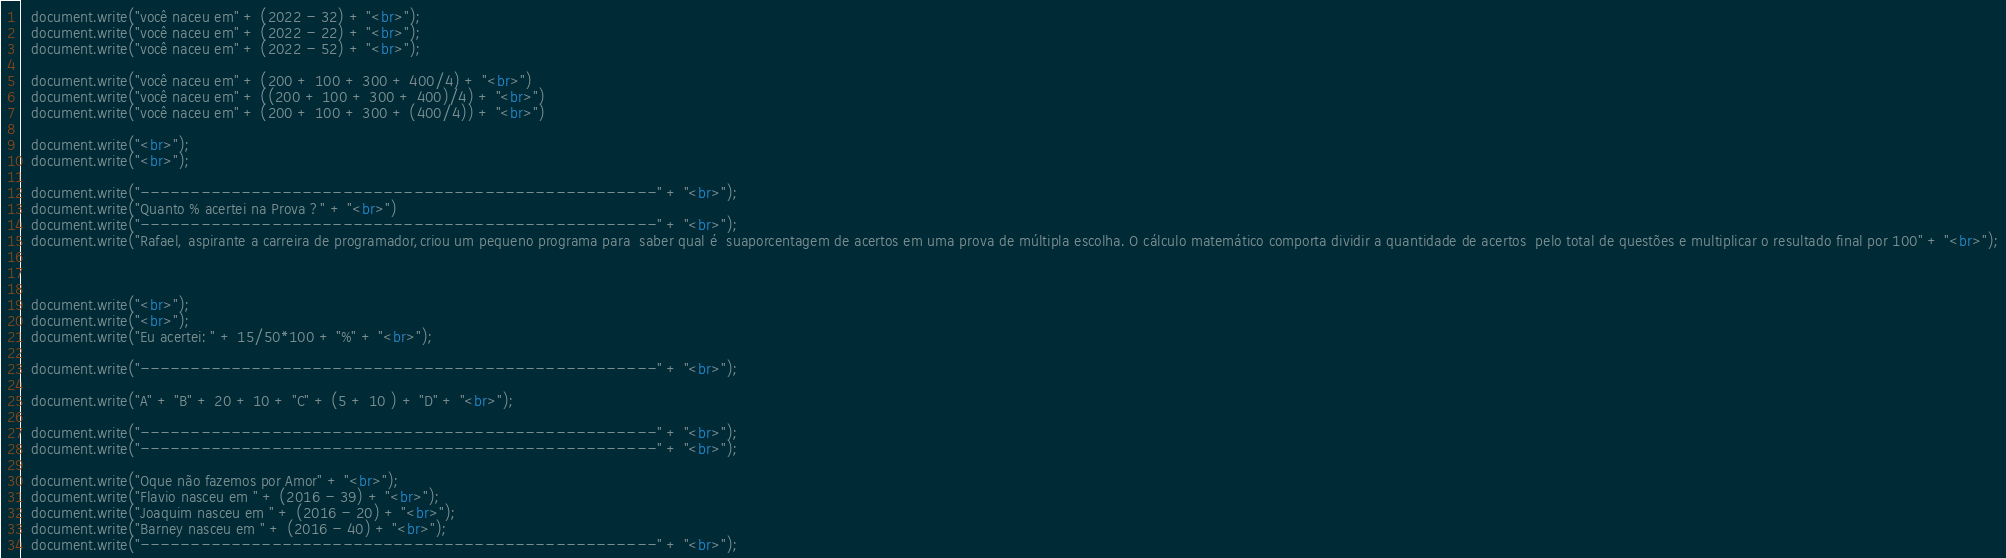Convert code to text. <code><loc_0><loc_0><loc_500><loc_500><_HTML_>
  document.write("você naceu em" + (2022 - 32) + "<br>");
  document.write("você naceu em" + (2022 - 22) + "<br>");
  document.write("você naceu em" + (2022 - 52) + "<br>");

  document.write("você naceu em" + (200 + 100 + 300 + 400/4) + "<br>")
  document.write("você naceu em" + ((200 + 100 + 300 + 400)/4) + "<br>")
  document.write("você naceu em" + (200 + 100 + 300 + (400/4)) + "<br>")

  document.write("<br>");
  document.write("<br>");

  document.write("---------------------------------------------------" + "<br>");
  document.write("Quanto % acertei na Prova ?" + "<br>")
  document.write("---------------------------------------------------" + "<br>");
  document.write("Rafael, aspirante a carreira de programador,criou um pequeno programa para  saber qual é  suaporcentagem de acertos em uma prova de múltipla escolha. O cálculo matemático comporta dividir a quantidade de acertos  pelo total de questões e multiplicar o resultado final por 100" + "<br>");
  


  document.write("<br>");
  document.write("<br>");
  document.write("Eu acertei: " + 15/50*100 + "%" + "<br>");

  document.write("---------------------------------------------------" + "<br>");

  document.write("A" + "B" + 20 + 10 + "C" + (5 + 10 ) + "D" + "<br>");

  document.write("---------------------------------------------------" + "<br>");
  document.write("---------------------------------------------------" + "<br>");

  document.write("Oque não fazemos por Amor" + "<br>");
  document.write("Flavio nasceu em " + (2016 - 39) + "<br>");
  document.write("Joaquim nasceu em " + (2016 - 20) + "<br>");
  document.write("Barney nasceu em " + (2016 - 40) + "<br>");
  document.write("---------------------------------------------------" + "<br>");
</code> 